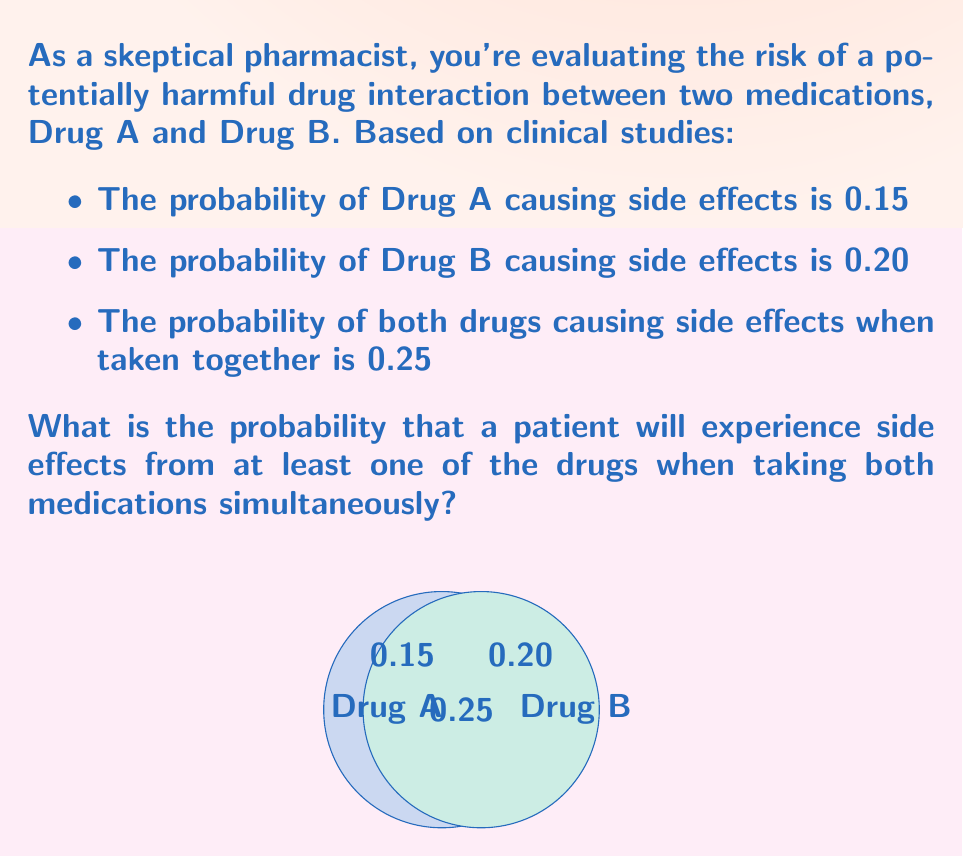Teach me how to tackle this problem. Let's approach this step-by-step using probabilistic logic:

1) Let A be the event of Drug A causing side effects, and B be the event of Drug B causing side effects.

2) We're given:
   P(A) = 0.15
   P(B) = 0.20
   P(A ∩ B) = 0.25 (probability of both drugs causing side effects)

3) We need to find P(A ∪ B), which is the probability of at least one drug causing side effects.

4) We can use the addition rule of probability:
   P(A ∪ B) = P(A) + P(B) - P(A ∩ B)

5) Substituting the values:
   P(A ∪ B) = 0.15 + 0.20 - 0.25

6) Calculating:
   P(A ∪ B) = 0.35 - 0.25 = 0.10

7) Therefore, the probability of experiencing side effects from at least one of the drugs is 0.10 or 10%.

This result might seem counterintuitive at first, which is why a skeptical approach is valuable. The lower-than-expected probability is due to the high overlap in side effects (0.25), suggesting that these drugs often cause side effects together rather than independently.
Answer: 0.10 or 10% 